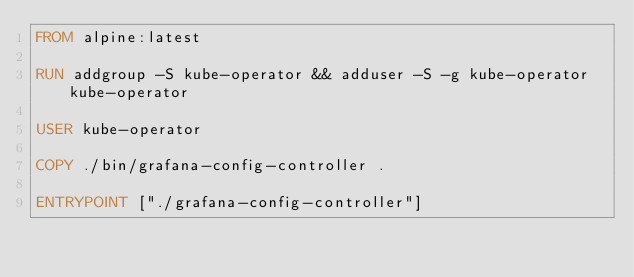Convert code to text. <code><loc_0><loc_0><loc_500><loc_500><_Dockerfile_>FROM alpine:latest

RUN addgroup -S kube-operator && adduser -S -g kube-operator kube-operator

USER kube-operator

COPY ./bin/grafana-config-controller .

ENTRYPOINT ["./grafana-config-controller"]
</code> 